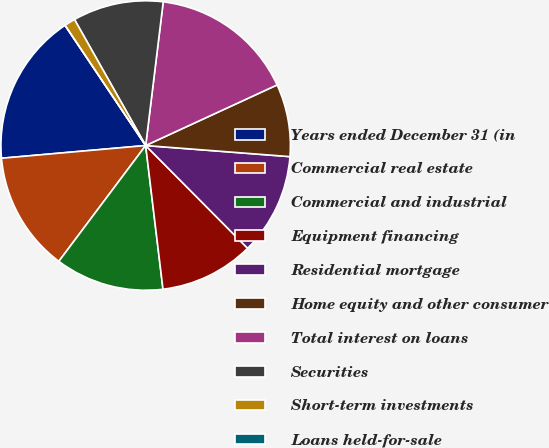<chart> <loc_0><loc_0><loc_500><loc_500><pie_chart><fcel>Years ended December 31 (in<fcel>Commercial real estate<fcel>Commercial and industrial<fcel>Equipment financing<fcel>Residential mortgage<fcel>Home equity and other consumer<fcel>Total interest on loans<fcel>Securities<fcel>Short-term investments<fcel>Loans held-for-sale<nl><fcel>17.0%<fcel>13.36%<fcel>12.15%<fcel>10.53%<fcel>11.34%<fcel>8.1%<fcel>16.19%<fcel>10.12%<fcel>1.22%<fcel>0.0%<nl></chart> 